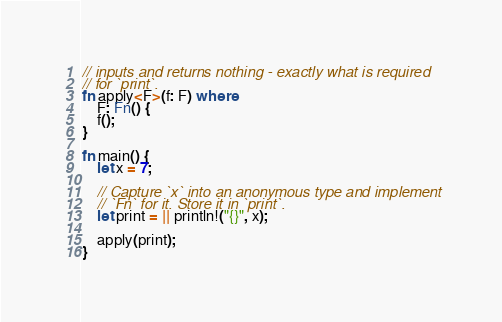<code> <loc_0><loc_0><loc_500><loc_500><_Rust_>// inputs and returns nothing - exactly what is required
// for `print`.
fn apply<F>(f: F) where
    F: Fn() {
    f();
}

fn main() {
    let x = 7;

    // Capture `x` into an anonymous type and implement
    // `Fn` for it. Store it in `print`.
    let print = || println!("{}", x);

    apply(print);
}
</code> 